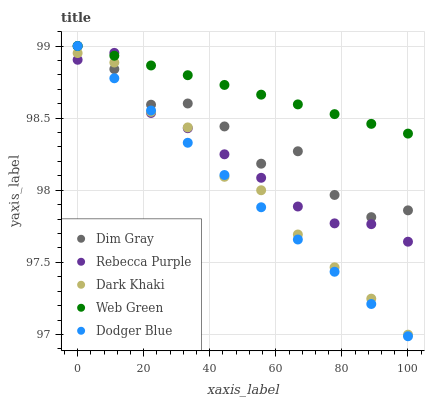Does Dodger Blue have the minimum area under the curve?
Answer yes or no. Yes. Does Web Green have the maximum area under the curve?
Answer yes or no. Yes. Does Dim Gray have the minimum area under the curve?
Answer yes or no. No. Does Dim Gray have the maximum area under the curve?
Answer yes or no. No. Is Web Green the smoothest?
Answer yes or no. Yes. Is Dim Gray the roughest?
Answer yes or no. Yes. Is Dodger Blue the smoothest?
Answer yes or no. No. Is Dodger Blue the roughest?
Answer yes or no. No. Does Dodger Blue have the lowest value?
Answer yes or no. Yes. Does Dim Gray have the lowest value?
Answer yes or no. No. Does Web Green have the highest value?
Answer yes or no. Yes. Does Rebecca Purple have the highest value?
Answer yes or no. No. Is Dark Khaki less than Web Green?
Answer yes or no. Yes. Is Web Green greater than Dark Khaki?
Answer yes or no. Yes. Does Rebecca Purple intersect Dim Gray?
Answer yes or no. Yes. Is Rebecca Purple less than Dim Gray?
Answer yes or no. No. Is Rebecca Purple greater than Dim Gray?
Answer yes or no. No. Does Dark Khaki intersect Web Green?
Answer yes or no. No. 